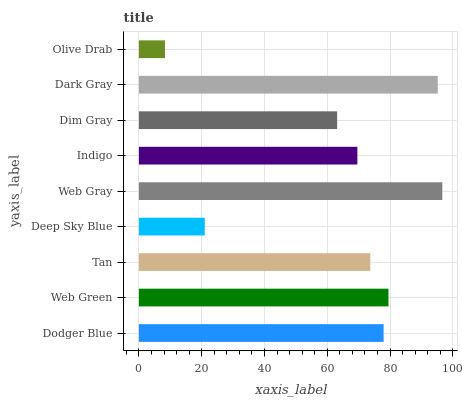Is Olive Drab the minimum?
Answer yes or no. Yes. Is Web Gray the maximum?
Answer yes or no. Yes. Is Web Green the minimum?
Answer yes or no. No. Is Web Green the maximum?
Answer yes or no. No. Is Web Green greater than Dodger Blue?
Answer yes or no. Yes. Is Dodger Blue less than Web Green?
Answer yes or no. Yes. Is Dodger Blue greater than Web Green?
Answer yes or no. No. Is Web Green less than Dodger Blue?
Answer yes or no. No. Is Tan the high median?
Answer yes or no. Yes. Is Tan the low median?
Answer yes or no. Yes. Is Dodger Blue the high median?
Answer yes or no. No. Is Web Green the low median?
Answer yes or no. No. 